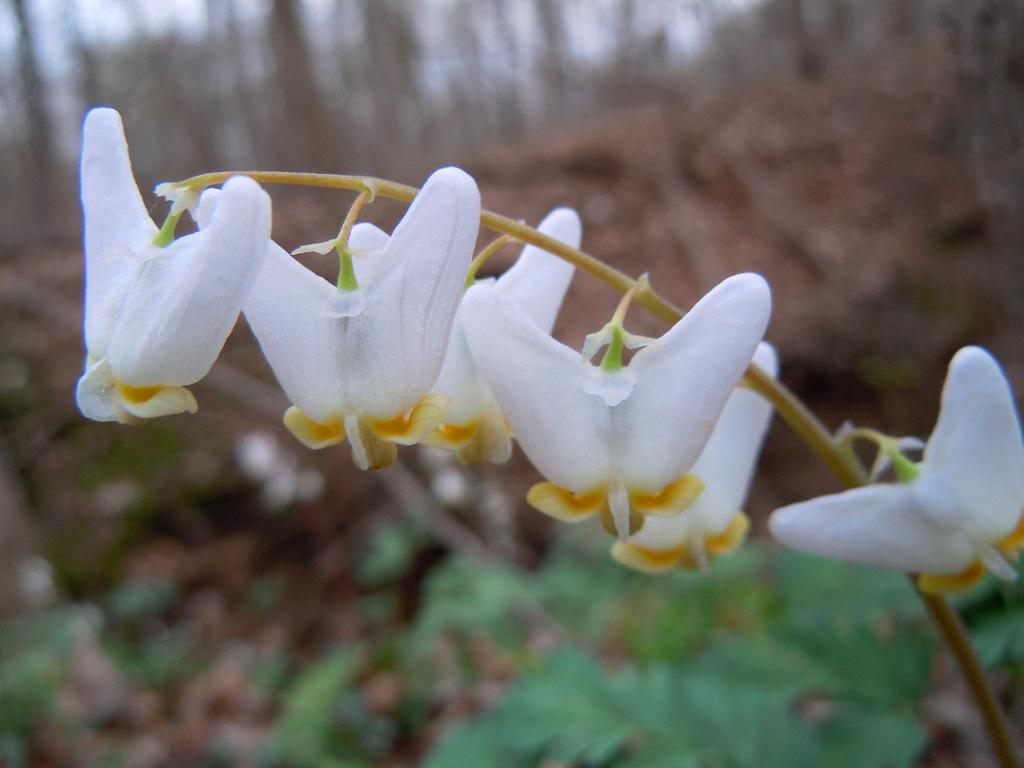What type of flowers can be seen in the image? There are white color flowers in the image. What do the flowers belong to? The flowers belong to a plant. How would you describe the background of the image? The background of the image is blurred. What can be seen in the distance in the image? Trees are visible in the background of the image. What type of stone is causing the basin to overflow in the image? There is no stone or basin present in the image; it features white color flowers and a blurred background. 